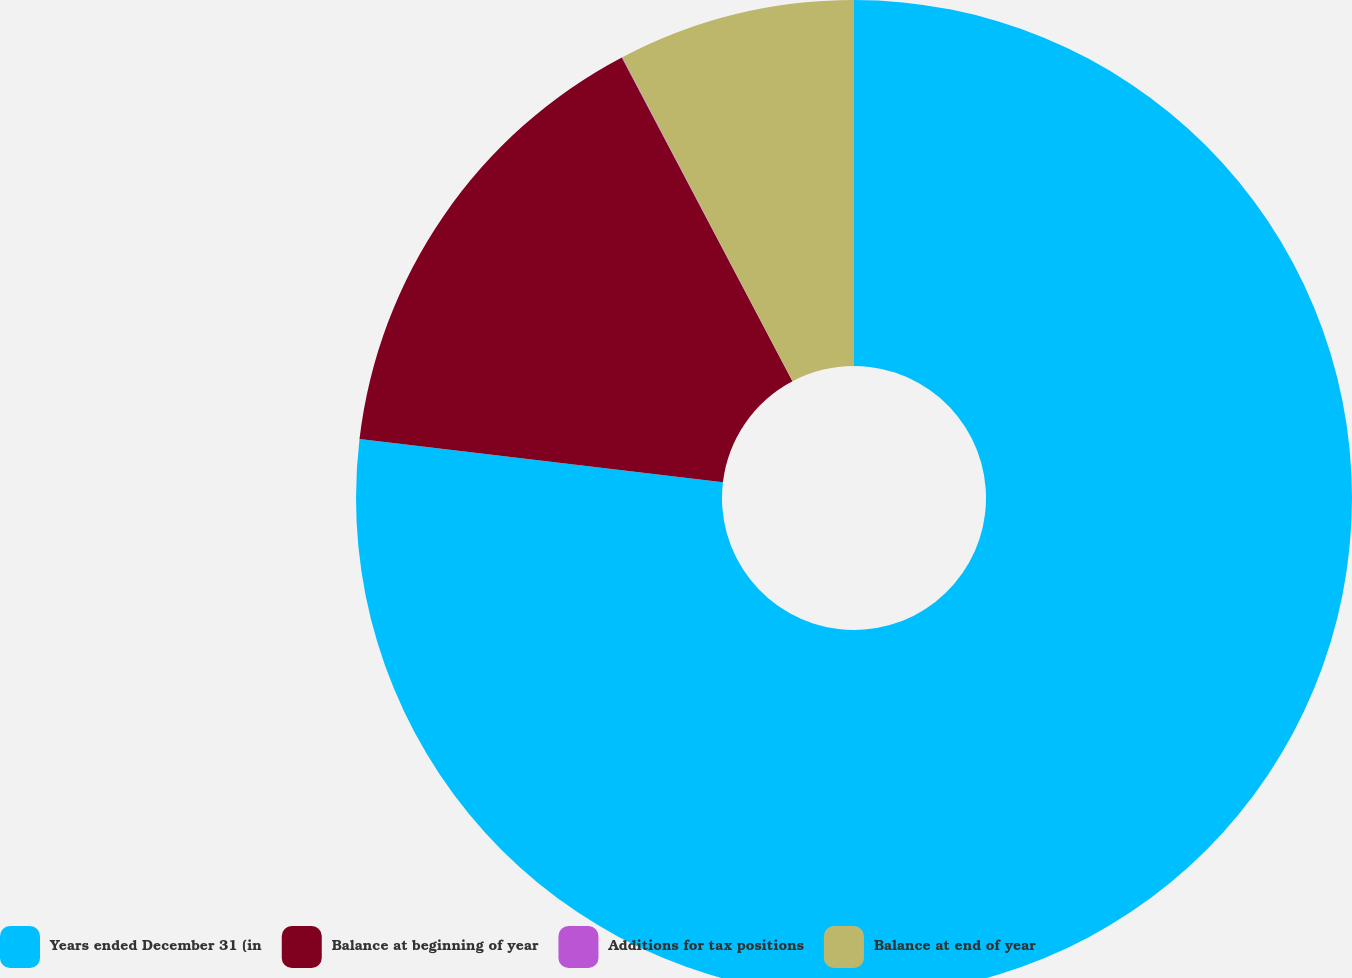Convert chart. <chart><loc_0><loc_0><loc_500><loc_500><pie_chart><fcel>Years ended December 31 (in<fcel>Balance at beginning of year<fcel>Additions for tax positions<fcel>Balance at end of year<nl><fcel>76.89%<fcel>15.39%<fcel>0.02%<fcel>7.7%<nl></chart> 